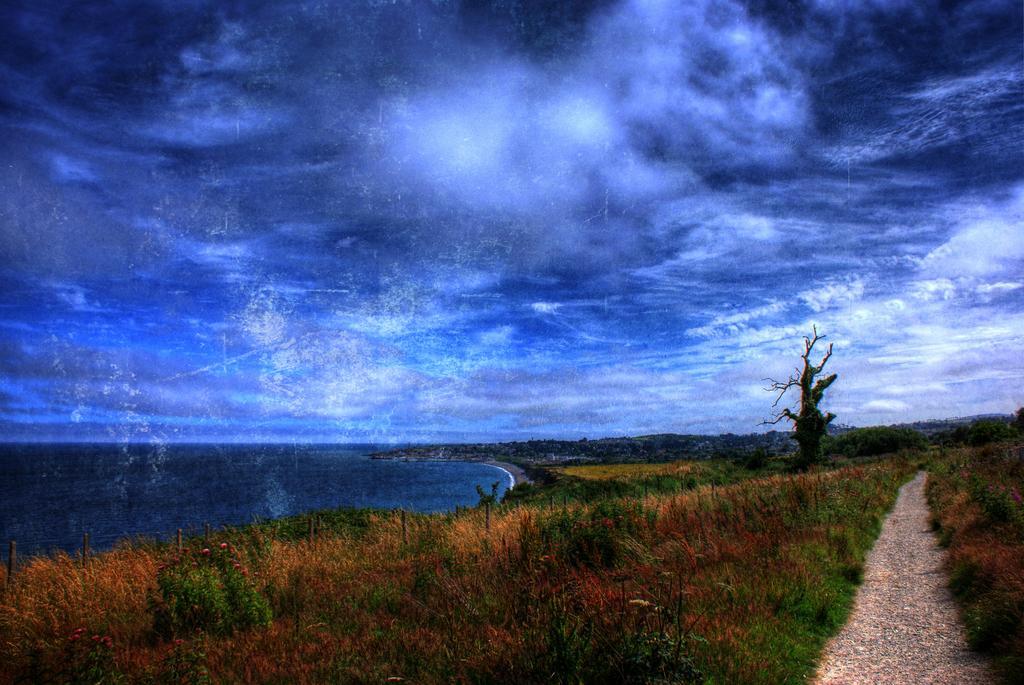In one or two sentences, can you explain what this image depicts? In this picture I can see a pond, cloudy sky, grass and the road. 